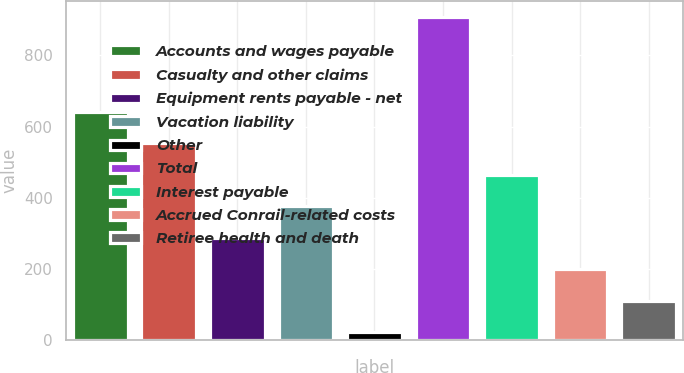Convert chart. <chart><loc_0><loc_0><loc_500><loc_500><bar_chart><fcel>Accounts and wages payable<fcel>Casualty and other claims<fcel>Equipment rents payable - net<fcel>Vacation liability<fcel>Other<fcel>Total<fcel>Interest payable<fcel>Accrued Conrail-related costs<fcel>Retiree health and death<nl><fcel>642.2<fcel>553.6<fcel>287.8<fcel>376.4<fcel>22<fcel>908<fcel>465<fcel>199.2<fcel>110.6<nl></chart> 